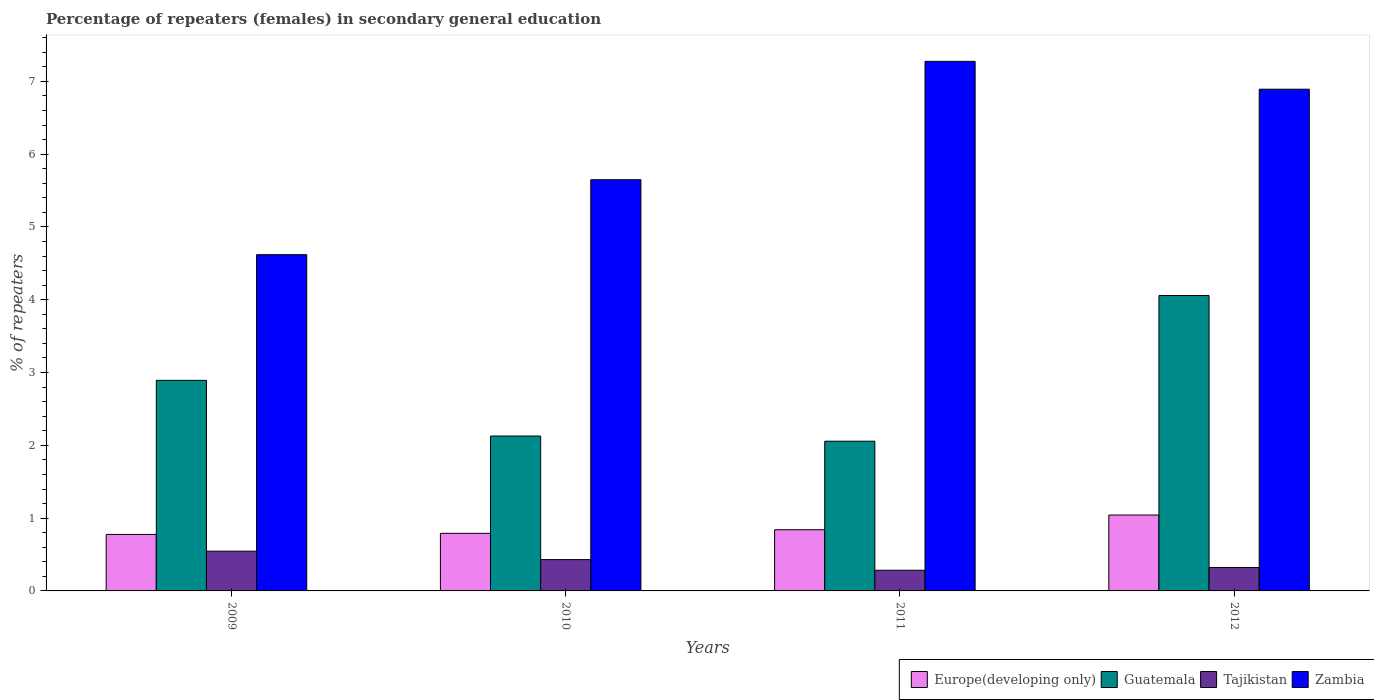How many different coloured bars are there?
Ensure brevity in your answer.  4. How many groups of bars are there?
Your answer should be very brief. 4. Are the number of bars per tick equal to the number of legend labels?
Provide a short and direct response. Yes. Are the number of bars on each tick of the X-axis equal?
Make the answer very short. Yes. How many bars are there on the 4th tick from the left?
Offer a terse response. 4. How many bars are there on the 1st tick from the right?
Your answer should be very brief. 4. What is the label of the 4th group of bars from the left?
Make the answer very short. 2012. What is the percentage of female repeaters in Europe(developing only) in 2009?
Provide a succinct answer. 0.78. Across all years, what is the maximum percentage of female repeaters in Zambia?
Provide a succinct answer. 7.27. Across all years, what is the minimum percentage of female repeaters in Europe(developing only)?
Your answer should be very brief. 0.78. What is the total percentage of female repeaters in Tajikistan in the graph?
Give a very brief answer. 1.58. What is the difference between the percentage of female repeaters in Tajikistan in 2011 and that in 2012?
Make the answer very short. -0.04. What is the difference between the percentage of female repeaters in Zambia in 2011 and the percentage of female repeaters in Tajikistan in 2012?
Make the answer very short. 6.95. What is the average percentage of female repeaters in Guatemala per year?
Provide a short and direct response. 2.78. In the year 2010, what is the difference between the percentage of female repeaters in Zambia and percentage of female repeaters in Europe(developing only)?
Give a very brief answer. 4.86. What is the ratio of the percentage of female repeaters in Guatemala in 2010 to that in 2011?
Provide a short and direct response. 1.03. Is the difference between the percentage of female repeaters in Zambia in 2009 and 2011 greater than the difference between the percentage of female repeaters in Europe(developing only) in 2009 and 2011?
Provide a succinct answer. No. What is the difference between the highest and the second highest percentage of female repeaters in Europe(developing only)?
Offer a terse response. 0.2. What is the difference between the highest and the lowest percentage of female repeaters in Guatemala?
Make the answer very short. 2. In how many years, is the percentage of female repeaters in Tajikistan greater than the average percentage of female repeaters in Tajikistan taken over all years?
Keep it short and to the point. 2. Is the sum of the percentage of female repeaters in Europe(developing only) in 2011 and 2012 greater than the maximum percentage of female repeaters in Tajikistan across all years?
Ensure brevity in your answer.  Yes. Is it the case that in every year, the sum of the percentage of female repeaters in Tajikistan and percentage of female repeaters in Zambia is greater than the sum of percentage of female repeaters in Europe(developing only) and percentage of female repeaters in Guatemala?
Your response must be concise. Yes. What does the 1st bar from the left in 2012 represents?
Your response must be concise. Europe(developing only). What does the 2nd bar from the right in 2009 represents?
Ensure brevity in your answer.  Tajikistan. Is it the case that in every year, the sum of the percentage of female repeaters in Guatemala and percentage of female repeaters in Zambia is greater than the percentage of female repeaters in Tajikistan?
Provide a short and direct response. Yes. How many bars are there?
Ensure brevity in your answer.  16. How many years are there in the graph?
Offer a very short reply. 4. What is the difference between two consecutive major ticks on the Y-axis?
Your answer should be compact. 1. How many legend labels are there?
Your answer should be very brief. 4. How are the legend labels stacked?
Provide a succinct answer. Horizontal. What is the title of the graph?
Provide a succinct answer. Percentage of repeaters (females) in secondary general education. Does "Heavily indebted poor countries" appear as one of the legend labels in the graph?
Your answer should be very brief. No. What is the label or title of the Y-axis?
Provide a short and direct response. % of repeaters. What is the % of repeaters of Europe(developing only) in 2009?
Your answer should be compact. 0.78. What is the % of repeaters in Guatemala in 2009?
Provide a short and direct response. 2.89. What is the % of repeaters of Tajikistan in 2009?
Give a very brief answer. 0.55. What is the % of repeaters in Zambia in 2009?
Your answer should be compact. 4.62. What is the % of repeaters of Europe(developing only) in 2010?
Offer a terse response. 0.79. What is the % of repeaters in Guatemala in 2010?
Offer a very short reply. 2.13. What is the % of repeaters of Tajikistan in 2010?
Your response must be concise. 0.43. What is the % of repeaters of Zambia in 2010?
Keep it short and to the point. 5.65. What is the % of repeaters in Europe(developing only) in 2011?
Make the answer very short. 0.84. What is the % of repeaters in Guatemala in 2011?
Your response must be concise. 2.06. What is the % of repeaters in Tajikistan in 2011?
Your answer should be very brief. 0.28. What is the % of repeaters of Zambia in 2011?
Provide a short and direct response. 7.27. What is the % of repeaters in Europe(developing only) in 2012?
Give a very brief answer. 1.04. What is the % of repeaters of Guatemala in 2012?
Your answer should be very brief. 4.06. What is the % of repeaters of Tajikistan in 2012?
Ensure brevity in your answer.  0.32. What is the % of repeaters of Zambia in 2012?
Your response must be concise. 6.89. Across all years, what is the maximum % of repeaters of Europe(developing only)?
Give a very brief answer. 1.04. Across all years, what is the maximum % of repeaters in Guatemala?
Keep it short and to the point. 4.06. Across all years, what is the maximum % of repeaters of Tajikistan?
Offer a very short reply. 0.55. Across all years, what is the maximum % of repeaters of Zambia?
Your answer should be compact. 7.27. Across all years, what is the minimum % of repeaters of Europe(developing only)?
Keep it short and to the point. 0.78. Across all years, what is the minimum % of repeaters of Guatemala?
Keep it short and to the point. 2.06. Across all years, what is the minimum % of repeaters in Tajikistan?
Give a very brief answer. 0.28. Across all years, what is the minimum % of repeaters of Zambia?
Your response must be concise. 4.62. What is the total % of repeaters of Europe(developing only) in the graph?
Your response must be concise. 3.45. What is the total % of repeaters in Guatemala in the graph?
Offer a very short reply. 11.14. What is the total % of repeaters in Tajikistan in the graph?
Offer a very short reply. 1.58. What is the total % of repeaters of Zambia in the graph?
Keep it short and to the point. 24.43. What is the difference between the % of repeaters in Europe(developing only) in 2009 and that in 2010?
Make the answer very short. -0.02. What is the difference between the % of repeaters of Guatemala in 2009 and that in 2010?
Offer a terse response. 0.77. What is the difference between the % of repeaters of Tajikistan in 2009 and that in 2010?
Provide a short and direct response. 0.12. What is the difference between the % of repeaters of Zambia in 2009 and that in 2010?
Your response must be concise. -1.03. What is the difference between the % of repeaters of Europe(developing only) in 2009 and that in 2011?
Offer a very short reply. -0.06. What is the difference between the % of repeaters in Guatemala in 2009 and that in 2011?
Your answer should be compact. 0.84. What is the difference between the % of repeaters in Tajikistan in 2009 and that in 2011?
Your answer should be very brief. 0.26. What is the difference between the % of repeaters in Zambia in 2009 and that in 2011?
Offer a very short reply. -2.66. What is the difference between the % of repeaters of Europe(developing only) in 2009 and that in 2012?
Make the answer very short. -0.27. What is the difference between the % of repeaters of Guatemala in 2009 and that in 2012?
Give a very brief answer. -1.17. What is the difference between the % of repeaters in Tajikistan in 2009 and that in 2012?
Provide a succinct answer. 0.22. What is the difference between the % of repeaters in Zambia in 2009 and that in 2012?
Your response must be concise. -2.27. What is the difference between the % of repeaters in Europe(developing only) in 2010 and that in 2011?
Your response must be concise. -0.05. What is the difference between the % of repeaters in Guatemala in 2010 and that in 2011?
Ensure brevity in your answer.  0.07. What is the difference between the % of repeaters of Tajikistan in 2010 and that in 2011?
Your answer should be compact. 0.15. What is the difference between the % of repeaters of Zambia in 2010 and that in 2011?
Give a very brief answer. -1.63. What is the difference between the % of repeaters of Europe(developing only) in 2010 and that in 2012?
Give a very brief answer. -0.25. What is the difference between the % of repeaters in Guatemala in 2010 and that in 2012?
Give a very brief answer. -1.93. What is the difference between the % of repeaters of Tajikistan in 2010 and that in 2012?
Provide a succinct answer. 0.11. What is the difference between the % of repeaters of Zambia in 2010 and that in 2012?
Provide a succinct answer. -1.24. What is the difference between the % of repeaters in Europe(developing only) in 2011 and that in 2012?
Offer a terse response. -0.2. What is the difference between the % of repeaters in Guatemala in 2011 and that in 2012?
Your answer should be compact. -2. What is the difference between the % of repeaters of Tajikistan in 2011 and that in 2012?
Ensure brevity in your answer.  -0.04. What is the difference between the % of repeaters in Zambia in 2011 and that in 2012?
Provide a succinct answer. 0.38. What is the difference between the % of repeaters in Europe(developing only) in 2009 and the % of repeaters in Guatemala in 2010?
Your response must be concise. -1.35. What is the difference between the % of repeaters in Europe(developing only) in 2009 and the % of repeaters in Tajikistan in 2010?
Your response must be concise. 0.35. What is the difference between the % of repeaters of Europe(developing only) in 2009 and the % of repeaters of Zambia in 2010?
Your response must be concise. -4.87. What is the difference between the % of repeaters of Guatemala in 2009 and the % of repeaters of Tajikistan in 2010?
Give a very brief answer. 2.46. What is the difference between the % of repeaters of Guatemala in 2009 and the % of repeaters of Zambia in 2010?
Provide a short and direct response. -2.76. What is the difference between the % of repeaters in Tajikistan in 2009 and the % of repeaters in Zambia in 2010?
Ensure brevity in your answer.  -5.1. What is the difference between the % of repeaters in Europe(developing only) in 2009 and the % of repeaters in Guatemala in 2011?
Your answer should be very brief. -1.28. What is the difference between the % of repeaters in Europe(developing only) in 2009 and the % of repeaters in Tajikistan in 2011?
Make the answer very short. 0.49. What is the difference between the % of repeaters of Europe(developing only) in 2009 and the % of repeaters of Zambia in 2011?
Provide a short and direct response. -6.5. What is the difference between the % of repeaters of Guatemala in 2009 and the % of repeaters of Tajikistan in 2011?
Provide a short and direct response. 2.61. What is the difference between the % of repeaters of Guatemala in 2009 and the % of repeaters of Zambia in 2011?
Provide a short and direct response. -4.38. What is the difference between the % of repeaters in Tajikistan in 2009 and the % of repeaters in Zambia in 2011?
Make the answer very short. -6.73. What is the difference between the % of repeaters of Europe(developing only) in 2009 and the % of repeaters of Guatemala in 2012?
Offer a very short reply. -3.28. What is the difference between the % of repeaters of Europe(developing only) in 2009 and the % of repeaters of Tajikistan in 2012?
Make the answer very short. 0.45. What is the difference between the % of repeaters in Europe(developing only) in 2009 and the % of repeaters in Zambia in 2012?
Make the answer very short. -6.12. What is the difference between the % of repeaters of Guatemala in 2009 and the % of repeaters of Tajikistan in 2012?
Provide a short and direct response. 2.57. What is the difference between the % of repeaters of Guatemala in 2009 and the % of repeaters of Zambia in 2012?
Keep it short and to the point. -4. What is the difference between the % of repeaters of Tajikistan in 2009 and the % of repeaters of Zambia in 2012?
Make the answer very short. -6.35. What is the difference between the % of repeaters in Europe(developing only) in 2010 and the % of repeaters in Guatemala in 2011?
Make the answer very short. -1.27. What is the difference between the % of repeaters in Europe(developing only) in 2010 and the % of repeaters in Tajikistan in 2011?
Ensure brevity in your answer.  0.51. What is the difference between the % of repeaters in Europe(developing only) in 2010 and the % of repeaters in Zambia in 2011?
Provide a succinct answer. -6.48. What is the difference between the % of repeaters of Guatemala in 2010 and the % of repeaters of Tajikistan in 2011?
Ensure brevity in your answer.  1.84. What is the difference between the % of repeaters of Guatemala in 2010 and the % of repeaters of Zambia in 2011?
Offer a very short reply. -5.15. What is the difference between the % of repeaters in Tajikistan in 2010 and the % of repeaters in Zambia in 2011?
Make the answer very short. -6.84. What is the difference between the % of repeaters of Europe(developing only) in 2010 and the % of repeaters of Guatemala in 2012?
Make the answer very short. -3.27. What is the difference between the % of repeaters in Europe(developing only) in 2010 and the % of repeaters in Tajikistan in 2012?
Your response must be concise. 0.47. What is the difference between the % of repeaters in Europe(developing only) in 2010 and the % of repeaters in Zambia in 2012?
Keep it short and to the point. -6.1. What is the difference between the % of repeaters in Guatemala in 2010 and the % of repeaters in Tajikistan in 2012?
Ensure brevity in your answer.  1.81. What is the difference between the % of repeaters in Guatemala in 2010 and the % of repeaters in Zambia in 2012?
Ensure brevity in your answer.  -4.76. What is the difference between the % of repeaters in Tajikistan in 2010 and the % of repeaters in Zambia in 2012?
Keep it short and to the point. -6.46. What is the difference between the % of repeaters in Europe(developing only) in 2011 and the % of repeaters in Guatemala in 2012?
Keep it short and to the point. -3.22. What is the difference between the % of repeaters of Europe(developing only) in 2011 and the % of repeaters of Tajikistan in 2012?
Give a very brief answer. 0.52. What is the difference between the % of repeaters in Europe(developing only) in 2011 and the % of repeaters in Zambia in 2012?
Give a very brief answer. -6.05. What is the difference between the % of repeaters in Guatemala in 2011 and the % of repeaters in Tajikistan in 2012?
Your answer should be very brief. 1.73. What is the difference between the % of repeaters of Guatemala in 2011 and the % of repeaters of Zambia in 2012?
Keep it short and to the point. -4.84. What is the difference between the % of repeaters of Tajikistan in 2011 and the % of repeaters of Zambia in 2012?
Ensure brevity in your answer.  -6.61. What is the average % of repeaters in Europe(developing only) per year?
Ensure brevity in your answer.  0.86. What is the average % of repeaters in Guatemala per year?
Your response must be concise. 2.78. What is the average % of repeaters in Tajikistan per year?
Keep it short and to the point. 0.4. What is the average % of repeaters in Zambia per year?
Your answer should be compact. 6.11. In the year 2009, what is the difference between the % of repeaters of Europe(developing only) and % of repeaters of Guatemala?
Your answer should be very brief. -2.12. In the year 2009, what is the difference between the % of repeaters of Europe(developing only) and % of repeaters of Tajikistan?
Give a very brief answer. 0.23. In the year 2009, what is the difference between the % of repeaters in Europe(developing only) and % of repeaters in Zambia?
Ensure brevity in your answer.  -3.84. In the year 2009, what is the difference between the % of repeaters in Guatemala and % of repeaters in Tajikistan?
Make the answer very short. 2.35. In the year 2009, what is the difference between the % of repeaters in Guatemala and % of repeaters in Zambia?
Ensure brevity in your answer.  -1.73. In the year 2009, what is the difference between the % of repeaters of Tajikistan and % of repeaters of Zambia?
Make the answer very short. -4.07. In the year 2010, what is the difference between the % of repeaters of Europe(developing only) and % of repeaters of Guatemala?
Your answer should be very brief. -1.34. In the year 2010, what is the difference between the % of repeaters of Europe(developing only) and % of repeaters of Tajikistan?
Offer a terse response. 0.36. In the year 2010, what is the difference between the % of repeaters of Europe(developing only) and % of repeaters of Zambia?
Your answer should be very brief. -4.86. In the year 2010, what is the difference between the % of repeaters of Guatemala and % of repeaters of Tajikistan?
Give a very brief answer. 1.7. In the year 2010, what is the difference between the % of repeaters in Guatemala and % of repeaters in Zambia?
Provide a succinct answer. -3.52. In the year 2010, what is the difference between the % of repeaters in Tajikistan and % of repeaters in Zambia?
Your answer should be very brief. -5.22. In the year 2011, what is the difference between the % of repeaters in Europe(developing only) and % of repeaters in Guatemala?
Your response must be concise. -1.22. In the year 2011, what is the difference between the % of repeaters of Europe(developing only) and % of repeaters of Tajikistan?
Keep it short and to the point. 0.56. In the year 2011, what is the difference between the % of repeaters of Europe(developing only) and % of repeaters of Zambia?
Your response must be concise. -6.43. In the year 2011, what is the difference between the % of repeaters of Guatemala and % of repeaters of Tajikistan?
Offer a very short reply. 1.77. In the year 2011, what is the difference between the % of repeaters in Guatemala and % of repeaters in Zambia?
Provide a succinct answer. -5.22. In the year 2011, what is the difference between the % of repeaters of Tajikistan and % of repeaters of Zambia?
Your response must be concise. -6.99. In the year 2012, what is the difference between the % of repeaters of Europe(developing only) and % of repeaters of Guatemala?
Offer a terse response. -3.02. In the year 2012, what is the difference between the % of repeaters in Europe(developing only) and % of repeaters in Tajikistan?
Make the answer very short. 0.72. In the year 2012, what is the difference between the % of repeaters of Europe(developing only) and % of repeaters of Zambia?
Your response must be concise. -5.85. In the year 2012, what is the difference between the % of repeaters in Guatemala and % of repeaters in Tajikistan?
Keep it short and to the point. 3.74. In the year 2012, what is the difference between the % of repeaters of Guatemala and % of repeaters of Zambia?
Your answer should be compact. -2.83. In the year 2012, what is the difference between the % of repeaters of Tajikistan and % of repeaters of Zambia?
Your response must be concise. -6.57. What is the ratio of the % of repeaters in Guatemala in 2009 to that in 2010?
Your answer should be compact. 1.36. What is the ratio of the % of repeaters of Tajikistan in 2009 to that in 2010?
Keep it short and to the point. 1.27. What is the ratio of the % of repeaters in Zambia in 2009 to that in 2010?
Give a very brief answer. 0.82. What is the ratio of the % of repeaters of Europe(developing only) in 2009 to that in 2011?
Provide a succinct answer. 0.92. What is the ratio of the % of repeaters in Guatemala in 2009 to that in 2011?
Offer a very short reply. 1.41. What is the ratio of the % of repeaters of Tajikistan in 2009 to that in 2011?
Your response must be concise. 1.93. What is the ratio of the % of repeaters in Zambia in 2009 to that in 2011?
Make the answer very short. 0.63. What is the ratio of the % of repeaters in Europe(developing only) in 2009 to that in 2012?
Keep it short and to the point. 0.74. What is the ratio of the % of repeaters of Guatemala in 2009 to that in 2012?
Your response must be concise. 0.71. What is the ratio of the % of repeaters in Tajikistan in 2009 to that in 2012?
Your answer should be very brief. 1.7. What is the ratio of the % of repeaters in Zambia in 2009 to that in 2012?
Keep it short and to the point. 0.67. What is the ratio of the % of repeaters in Europe(developing only) in 2010 to that in 2011?
Offer a terse response. 0.94. What is the ratio of the % of repeaters of Guatemala in 2010 to that in 2011?
Make the answer very short. 1.03. What is the ratio of the % of repeaters in Tajikistan in 2010 to that in 2011?
Provide a short and direct response. 1.52. What is the ratio of the % of repeaters in Zambia in 2010 to that in 2011?
Your answer should be very brief. 0.78. What is the ratio of the % of repeaters in Europe(developing only) in 2010 to that in 2012?
Your response must be concise. 0.76. What is the ratio of the % of repeaters of Guatemala in 2010 to that in 2012?
Provide a short and direct response. 0.52. What is the ratio of the % of repeaters in Tajikistan in 2010 to that in 2012?
Give a very brief answer. 1.34. What is the ratio of the % of repeaters in Zambia in 2010 to that in 2012?
Keep it short and to the point. 0.82. What is the ratio of the % of repeaters in Europe(developing only) in 2011 to that in 2012?
Ensure brevity in your answer.  0.81. What is the ratio of the % of repeaters of Guatemala in 2011 to that in 2012?
Offer a very short reply. 0.51. What is the ratio of the % of repeaters of Tajikistan in 2011 to that in 2012?
Your answer should be very brief. 0.88. What is the ratio of the % of repeaters in Zambia in 2011 to that in 2012?
Offer a terse response. 1.06. What is the difference between the highest and the second highest % of repeaters in Europe(developing only)?
Make the answer very short. 0.2. What is the difference between the highest and the second highest % of repeaters in Guatemala?
Offer a terse response. 1.17. What is the difference between the highest and the second highest % of repeaters in Tajikistan?
Provide a succinct answer. 0.12. What is the difference between the highest and the second highest % of repeaters in Zambia?
Provide a succinct answer. 0.38. What is the difference between the highest and the lowest % of repeaters of Europe(developing only)?
Offer a very short reply. 0.27. What is the difference between the highest and the lowest % of repeaters in Guatemala?
Keep it short and to the point. 2. What is the difference between the highest and the lowest % of repeaters of Tajikistan?
Your response must be concise. 0.26. What is the difference between the highest and the lowest % of repeaters in Zambia?
Your answer should be very brief. 2.66. 